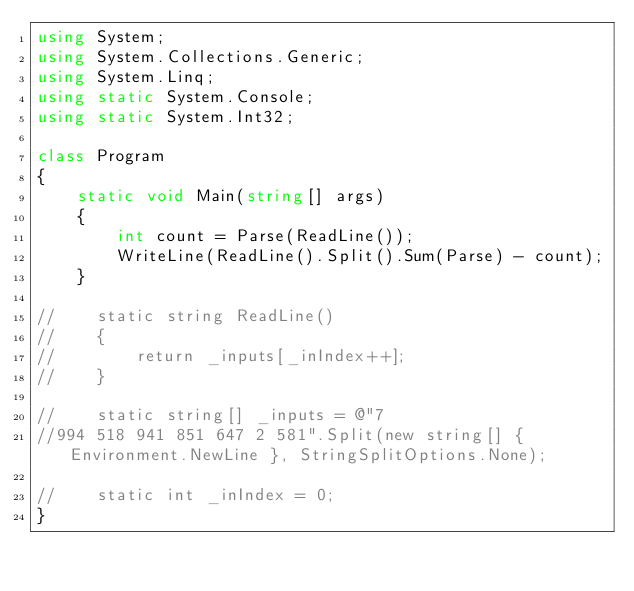Convert code to text. <code><loc_0><loc_0><loc_500><loc_500><_C#_>using System;
using System.Collections.Generic;
using System.Linq;
using static System.Console;
using static System.Int32;

class Program
{
    static void Main(string[] args)
    {
        int count = Parse(ReadLine());
        WriteLine(ReadLine().Split().Sum(Parse) - count);
    }

//    static string ReadLine()
//    {
//        return _inputs[_inIndex++];
//    }

//    static string[] _inputs = @"7
//994 518 941 851 647 2 581".Split(new string[] { Environment.NewLine }, StringSplitOptions.None);

//    static int _inIndex = 0;
}
</code> 